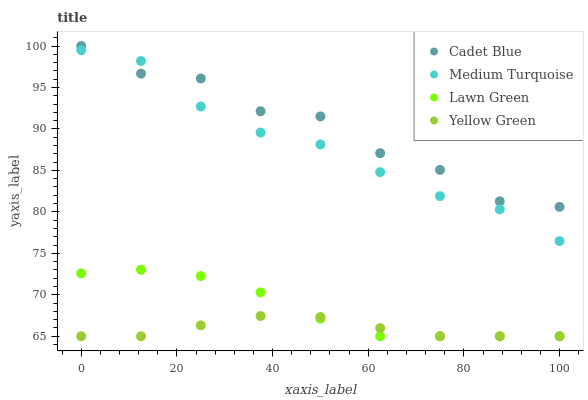Does Yellow Green have the minimum area under the curve?
Answer yes or no. Yes. Does Cadet Blue have the maximum area under the curve?
Answer yes or no. Yes. Does Cadet Blue have the minimum area under the curve?
Answer yes or no. No. Does Yellow Green have the maximum area under the curve?
Answer yes or no. No. Is Yellow Green the smoothest?
Answer yes or no. Yes. Is Cadet Blue the roughest?
Answer yes or no. Yes. Is Cadet Blue the smoothest?
Answer yes or no. No. Is Yellow Green the roughest?
Answer yes or no. No. Does Lawn Green have the lowest value?
Answer yes or no. Yes. Does Cadet Blue have the lowest value?
Answer yes or no. No. Does Cadet Blue have the highest value?
Answer yes or no. Yes. Does Yellow Green have the highest value?
Answer yes or no. No. Is Lawn Green less than Cadet Blue?
Answer yes or no. Yes. Is Cadet Blue greater than Yellow Green?
Answer yes or no. Yes. Does Lawn Green intersect Yellow Green?
Answer yes or no. Yes. Is Lawn Green less than Yellow Green?
Answer yes or no. No. Is Lawn Green greater than Yellow Green?
Answer yes or no. No. Does Lawn Green intersect Cadet Blue?
Answer yes or no. No. 